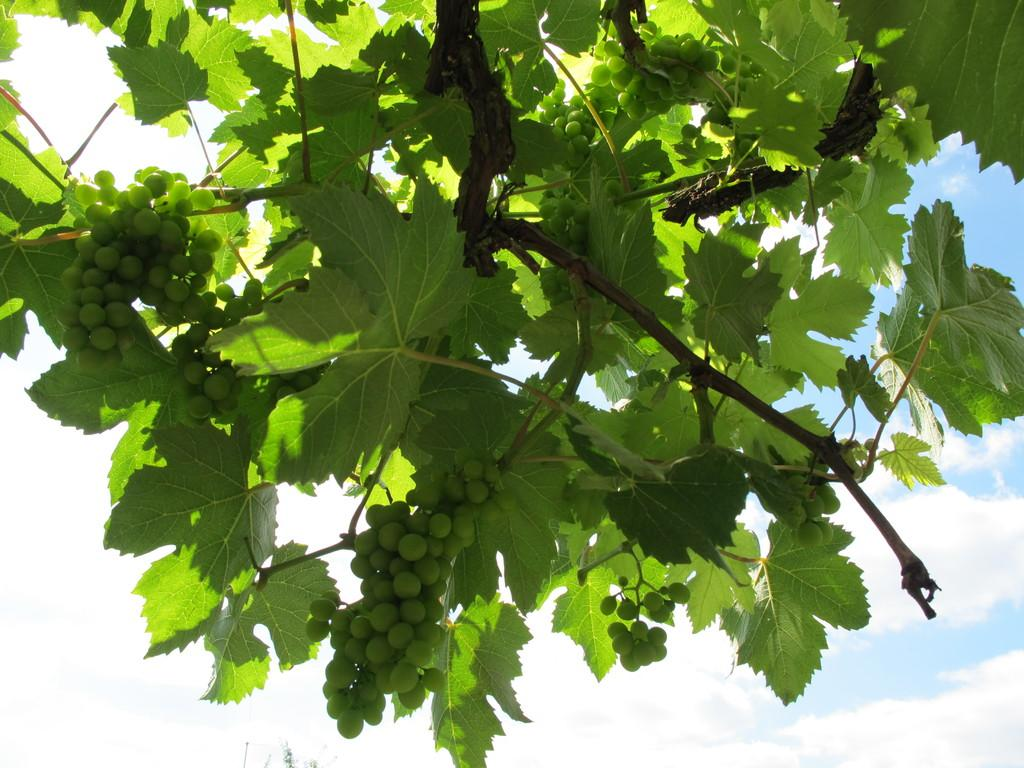What is the main subject in the image? There is a tree in the image. What can be seen on the tree? There are green color objects on the tree. Can you touch the tree in the image? You cannot touch the tree in the image, as it is a two-dimensional representation. What type of fork is visible in the image? There is no fork present in the image. 